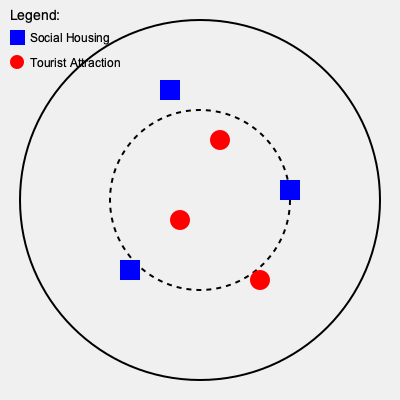Based on the map diagram, which shows the distribution of social housing units and tourist attractions in a city, what conclusion can be drawn about the spatial relationship between these two types of urban features? To analyze the spatial relationship between social housing units and tourist attractions, we need to examine their distribution patterns:

1. Social Housing Units (blue squares):
   - Located at (160, 80), (280, 180), and (120, 260)
   - Distributed across different areas of the city
   - Two units are in the outer ring, one is in the inner circle

2. Tourist Attractions (red circles):
   - Located at (220, 140), (180, 220), and (260, 280)
   - Also distributed across different areas of the city
   - Two attractions are in the outer ring, one is in the inner circle

3. Spatial Analysis:
   - Both types of features are spread throughout the city
   - There is no clear clustering of either type
   - Social housing units and tourist attractions are not concentrated in specific zones

4. Distance from City Center:
   - The dashed circle represents the inner city area
   - Both types of features are present in the inner and outer areas
   - There is no evident preference for central or peripheral locations for either type

5. Proximity:
   - There are no instances where social housing and tourist attractions are immediately adjacent
   - However, they are not entirely segregated either

Given these observations, we can conclude that there is a relatively even distribution of both social housing units and tourist attractions throughout the city, with no clear pattern of segregation or concentration in specific areas.
Answer: Even distribution with no clear segregation 